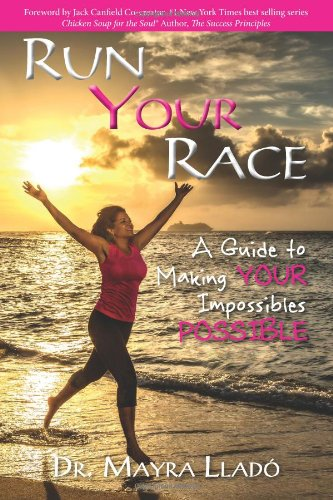Is this book related to Self-Help? Yes, this book is firmly in the Self-Help category, providing a pathway and strategies for readers to overcome their challenges and reach their aspirations. 